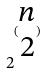<formula> <loc_0><loc_0><loc_500><loc_500>2 ^ { ( \begin{matrix} n \\ 2 \end{matrix} ) }</formula> 